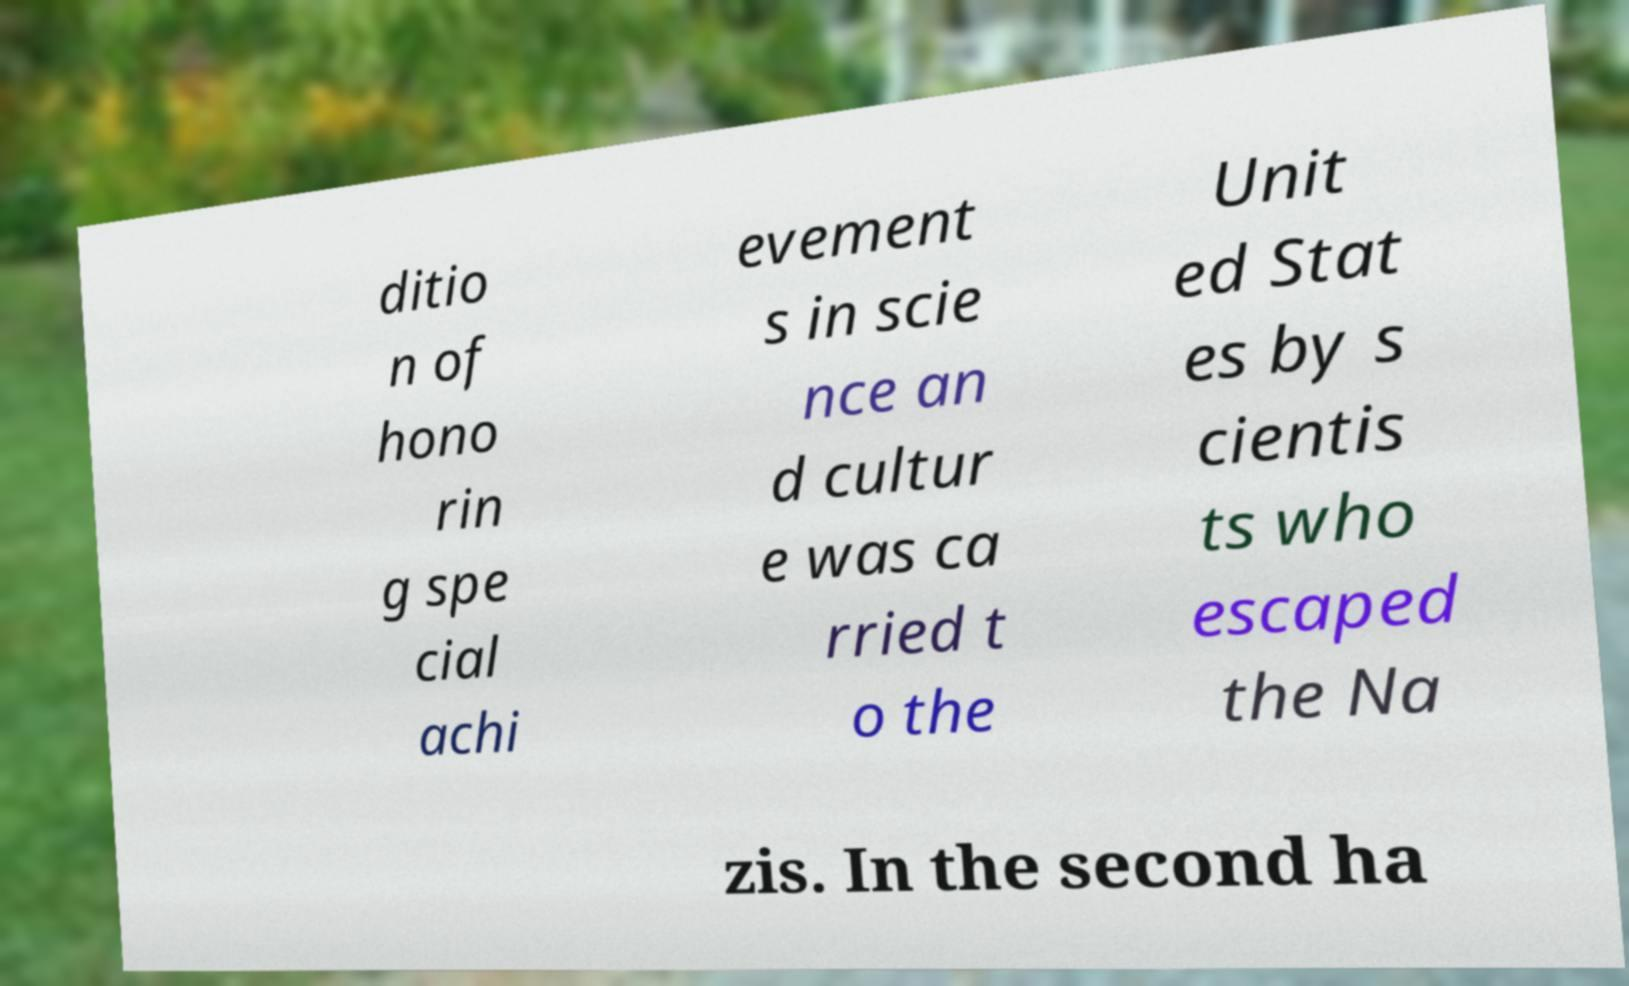Please identify and transcribe the text found in this image. ditio n of hono rin g spe cial achi evement s in scie nce an d cultur e was ca rried t o the Unit ed Stat es by s cientis ts who escaped the Na zis. In the second ha 